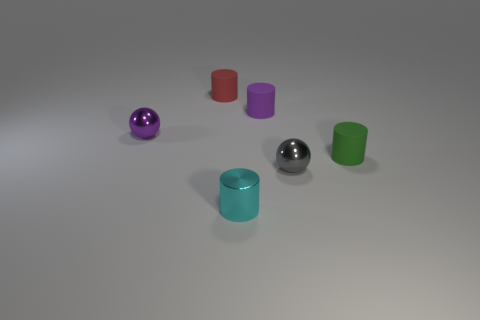Can the arrangement of these objects tell us anything about their purpose or the context in which they might be used? The objects seem to be deliberately placed with space between them, which might suggest they are being displayed or are part of a set. Without additional context, it's difficult to determine a specific purpose, but they could be educational models demonstrating shapes and colors, or perhaps decorative items. 